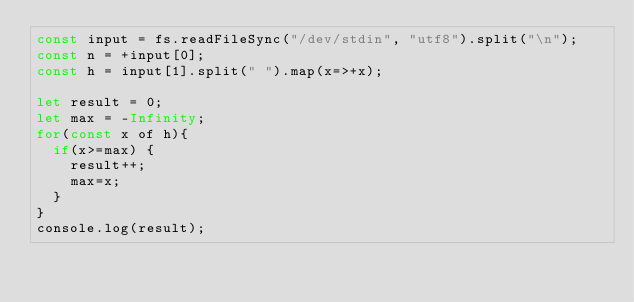<code> <loc_0><loc_0><loc_500><loc_500><_JavaScript_>const input = fs.readFileSync("/dev/stdin", "utf8").split("\n");
const n = +input[0];
const h = input[1].split(" ").map(x=>+x);

let result = 0;
let max = -Infinity;
for(const x of h){
  if(x>=max) {
    result++;
    max=x;
  }
}
console.log(result);
</code> 